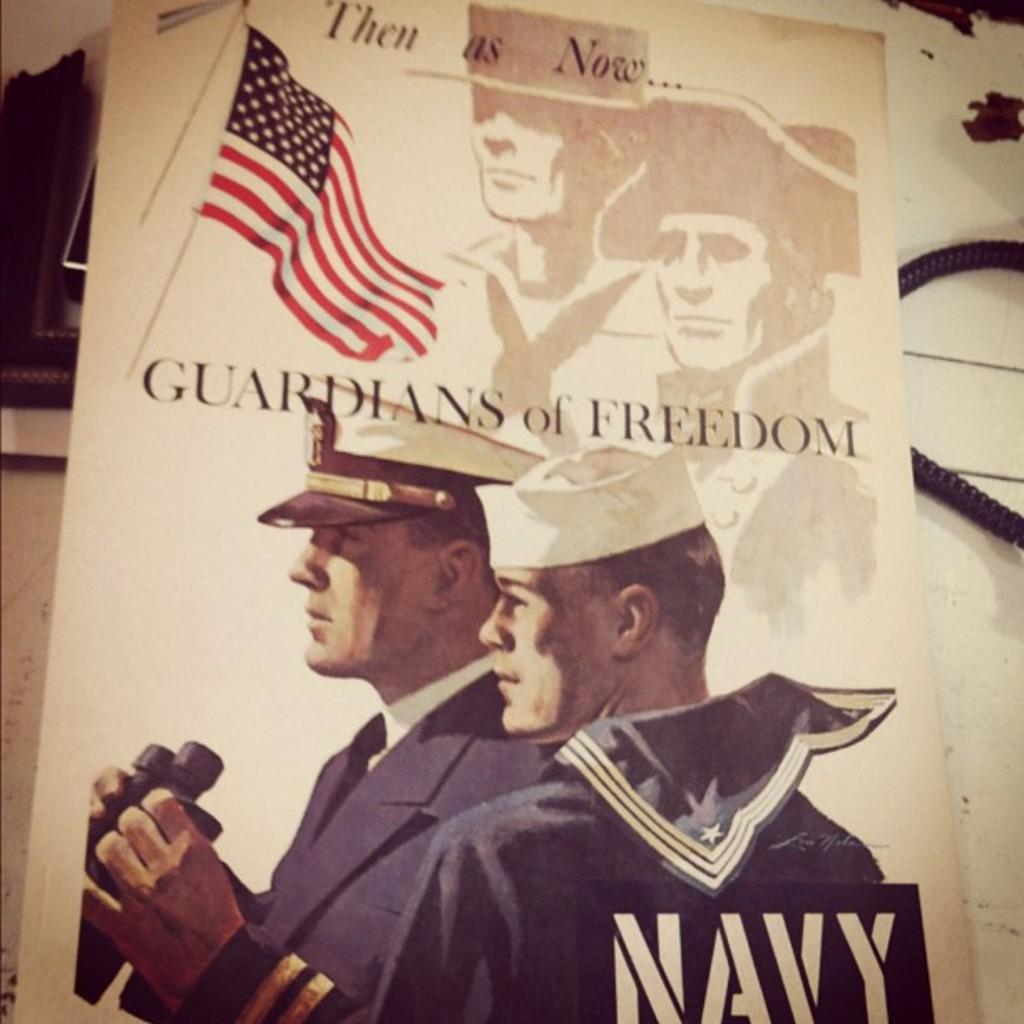What is featured on the poster in the image? The poster contains two people and a flag. What else can be seen on the poster? There is writing on the poster. Where is the telephone wire located in the image? The telephone wire is in the right corner of the image. What type of whip is being used by the people on the poster? There is no whip present on the poster; it only features two people, a flag, and writing. 